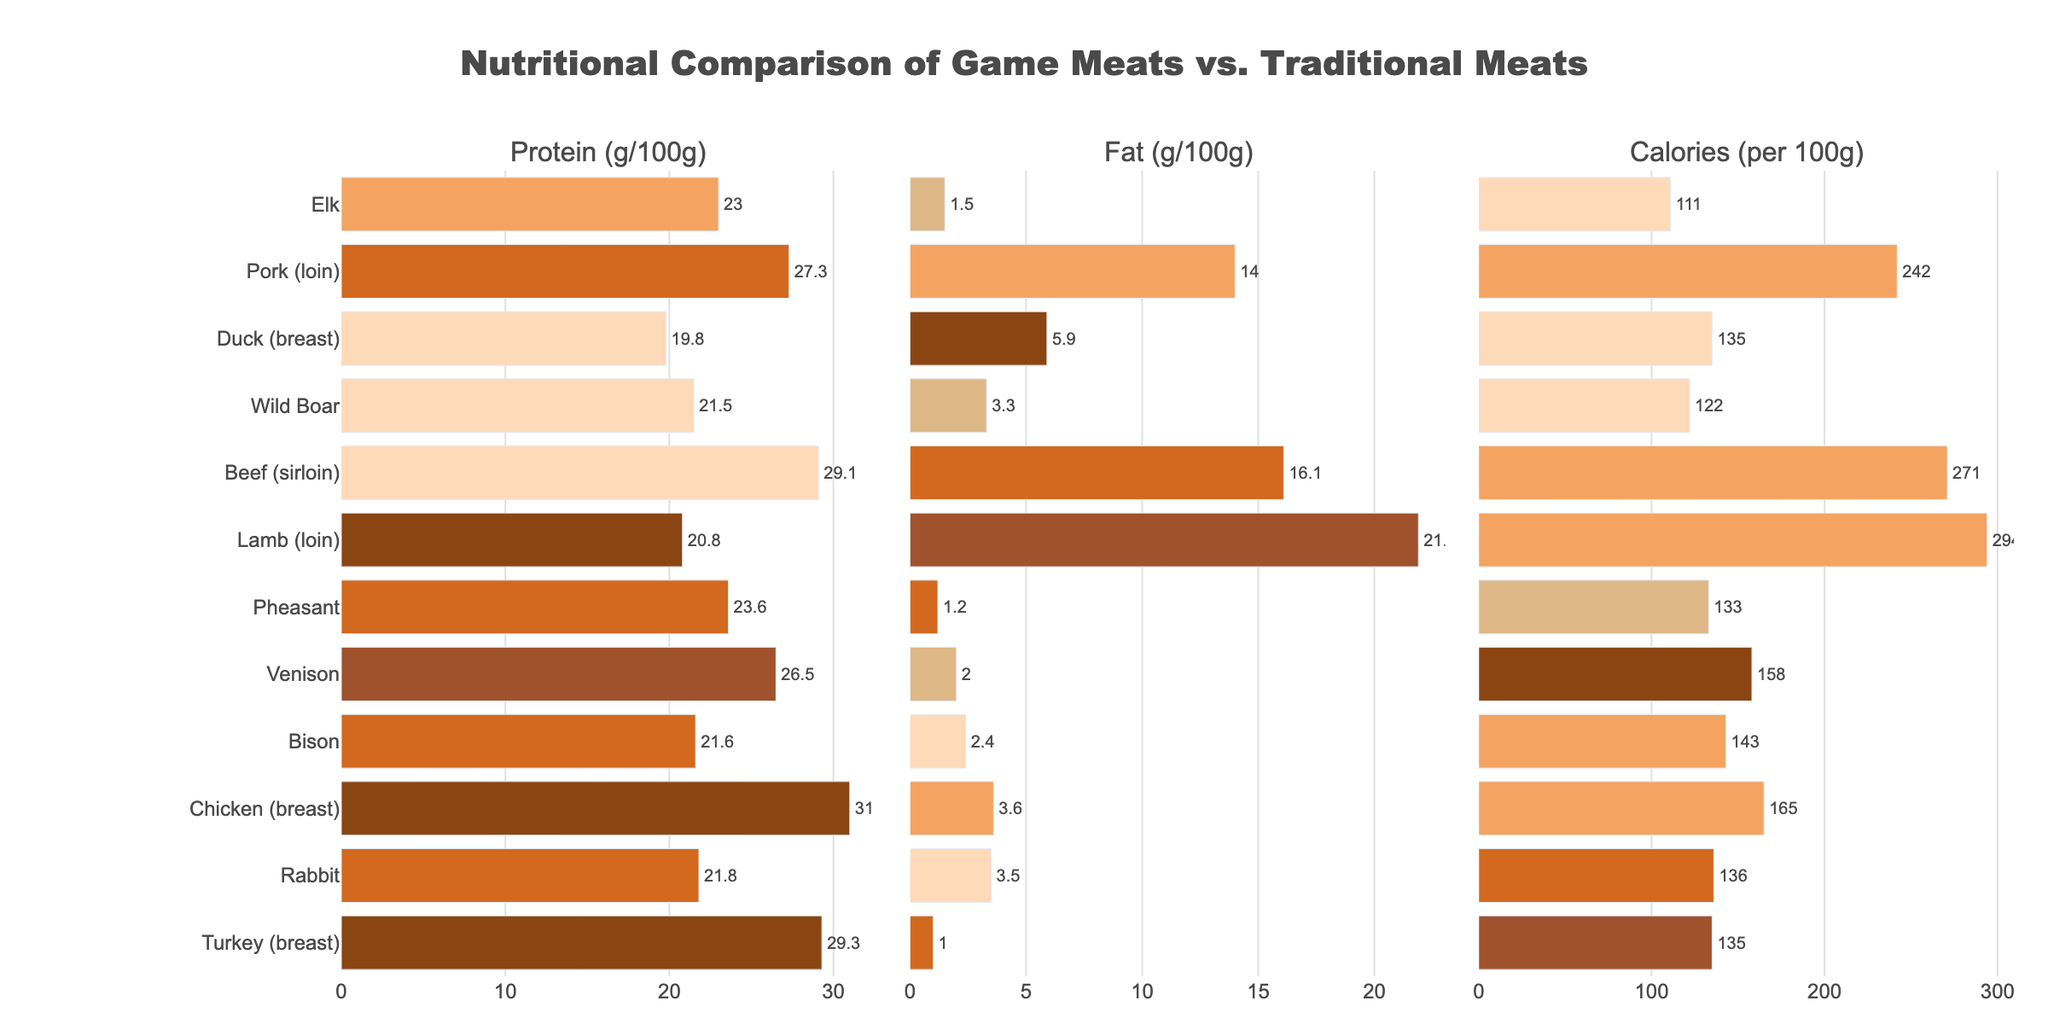Which meat has the highest protein content per 100g? Look at the "Protein (g/100g)" bar chart and identify the meat with the longest bar. Chicken breast has the longest bar indicating the highest protein content.
Answer: Chicken breast How does the fat content in venison compare to beef sirloin? Refer to the "Fat (g/100g)" bar chart. Compare the length of the bars for venison and beef sirloin. Venison has a much shorter bar than beef sirloin, indicating that venison has less fat.
Answer: Venison has less fat What's the difference in calories between lamb loin and turkey breast? Check the "Calories (per 100g)" bar chart. Note the bar lengths for lamb loin and turkey breast. Calculate the difference: 294 (lamb loin) - 135 (turkey breast) = 159.
Answer: 159 Which meat has the least amount of fat per 100g? Examine the "Fat (g/100g)" bar chart and identify the meat with the shortest bar. Turkey breast has the shortest bar, indicating the least fat content.
Answer: Turkey breast What is the average protein content for pork loin, duck breast, and wild boar? Find the bars for these meats in the "Protein (g/100g)" bar chart. Sum their protein values and divide by 3: (27.3 + 19.8 + 21.5) / 3 = 68.6 / 3 = 22.9.
Answer: 22.9 How do the caloric contents of game meats (like venison, wild boar, elk, rabbit, pheasant, bison) compare to traditional meats (beef sirloin, pork loin, chicken breast, lamb loin, turkey breast, duck breast)? Compare the bar lengths in the "Calories (per 100g)" chart for game meats vs. traditional meats. Game meats generally have shorter bars, indicating lower calorie contents.
Answer: Game meats generally have fewer calories Which meat type has the lowest protein content, and what is it? Look at the "Protein (g/100g)" bar chart and find the shortest bar. Lamb loin has the shortest bar with a protein content of 20.8 g/100g.
Answer: Lamb loin, 20.8 Is there a meat in the "Protein (g/100g)" chart that has a visually distinctive color? Identify any unique color among the bars in the "Protein (g/100g)" chart. The bar for elk has a distinctive light brown color.
Answer: Elk 